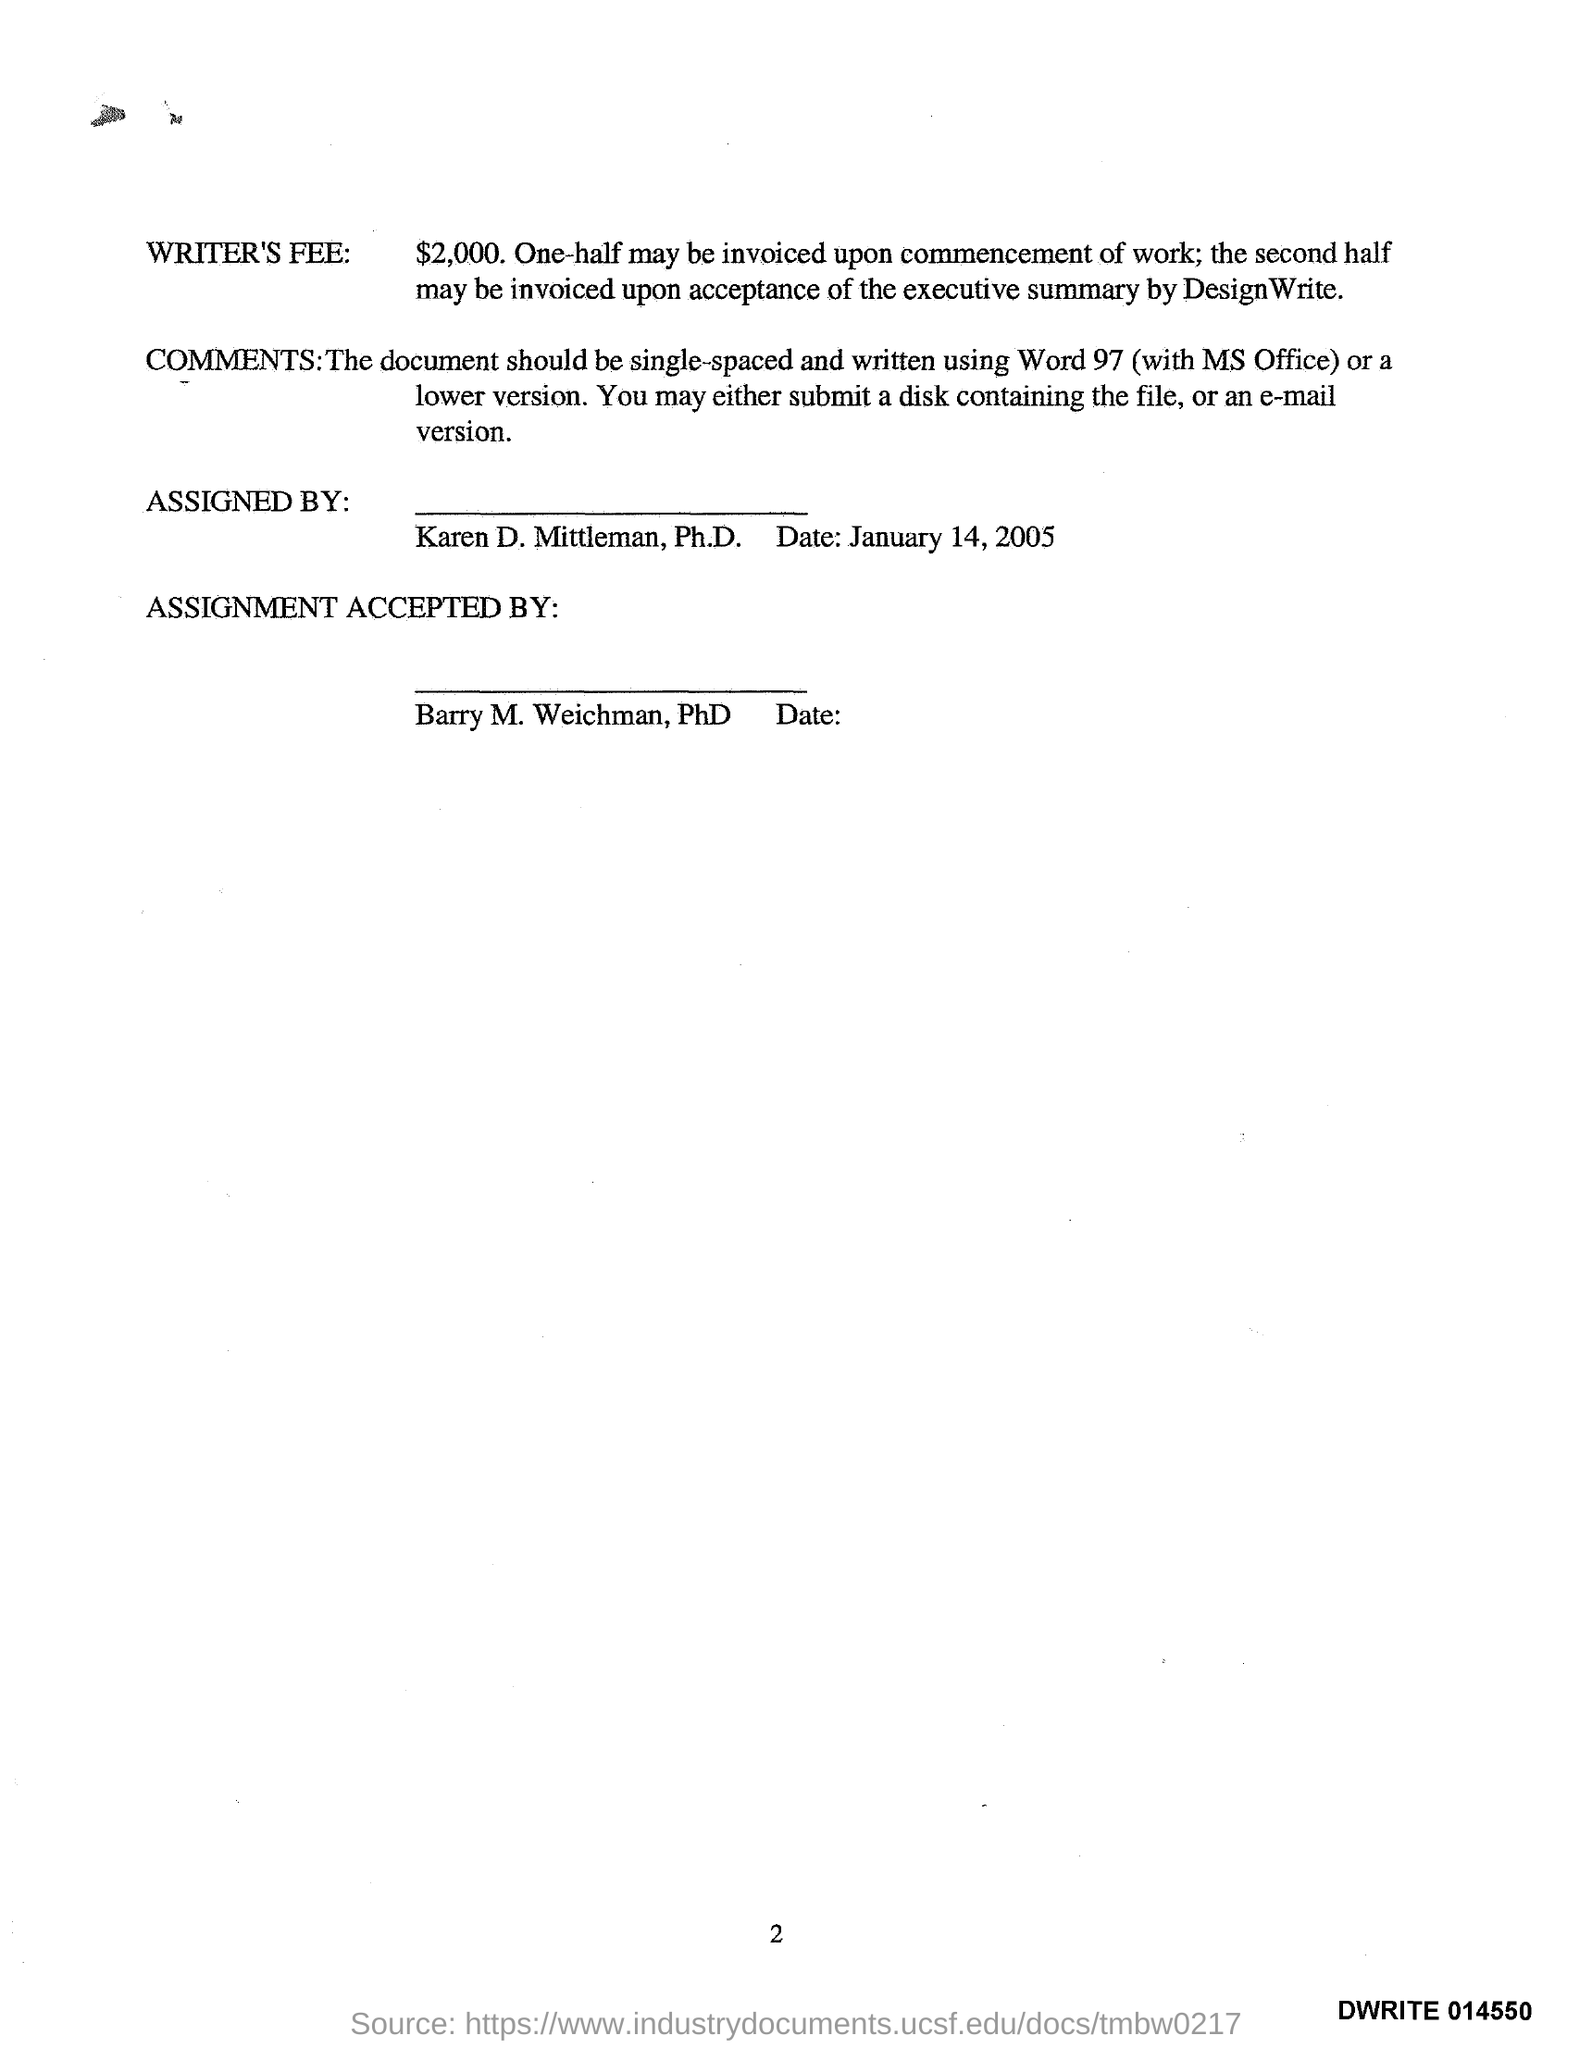What is the date mentioned?
Provide a succinct answer. January 14, 2005. By whom was this ASSIGNMENT Accepted?
Keep it short and to the point. Barry M. Weichman. What is the amount of WRITER'S FEE?
Provide a short and direct response. $2000. 